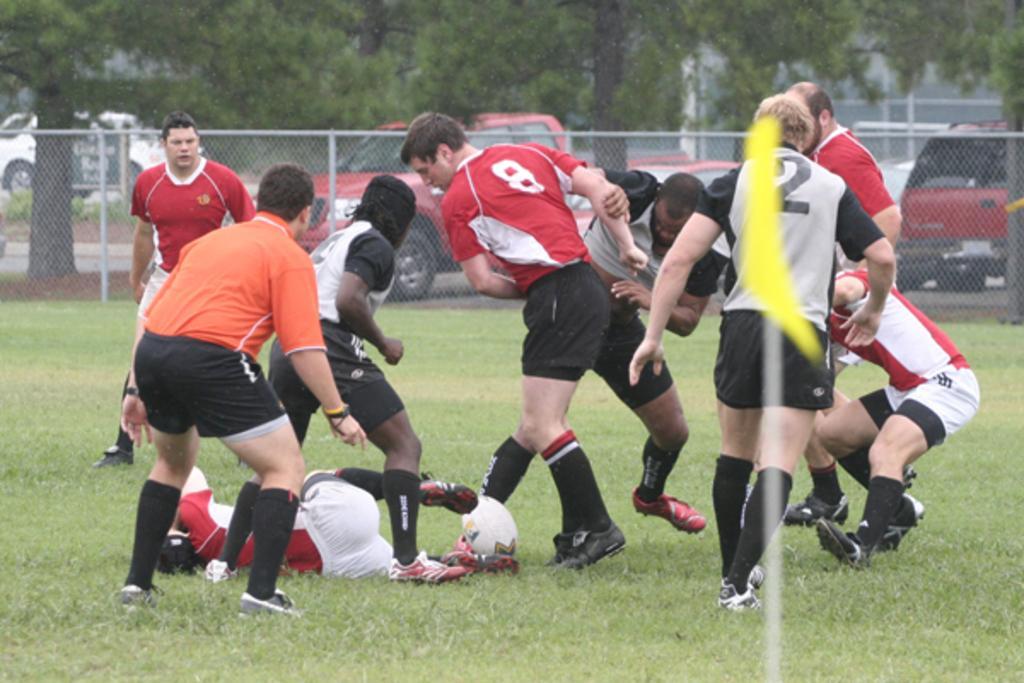Can you describe this image briefly? This is a playing ground. Here I can see few men wearing sports dresses and playing with a ball. At the bottom, I can see the grass on the ground. In the foreground there is a yellow color flag to a pole. In the background there is a net fencing. Behind the net fencing, I can see few vehicles on the road. In the background there are many trees. 